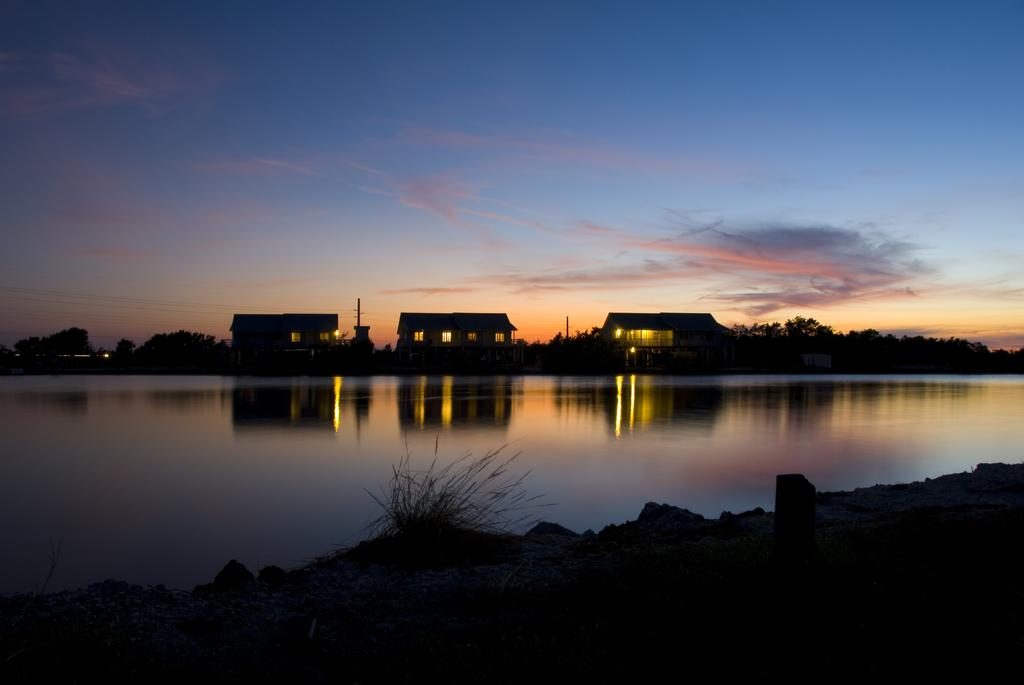What can be seen in the sky in the image? The sky with clouds is visible in the image. What type of structures are present in the image? There are buildings in the image. What are the poles used for in the image? The purpose of the poles is not specified in the image, but they could be used for various purposes such as signage or utility lines. What type of vegetation is visible in the image? Trees and shrubs are visible in the image. What body of water is present in the image? There is a river in the image. What type of terrain is visible in the image? Stones are visible in the image, suggesting a rocky or stony terrain. What type of flower is growing near the river in the image? There are no flowers visible in the image; only trees, shrubs, and stones are present near the river. 